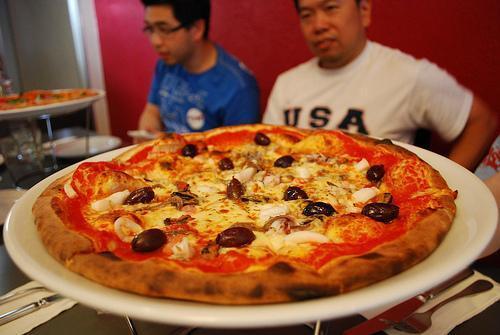How many people are pictured?
Give a very brief answer. 2. 